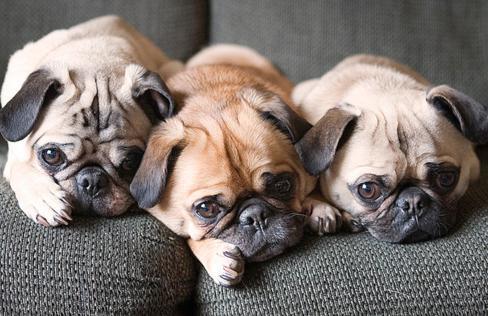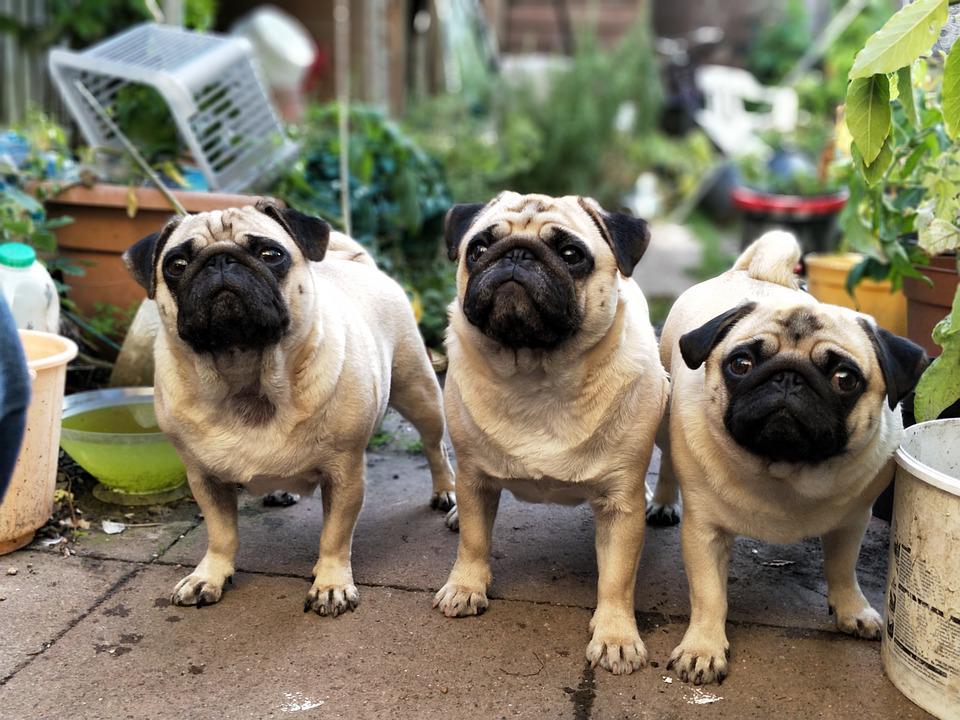The first image is the image on the left, the second image is the image on the right. For the images shown, is this caption "Three dogs are on a wooden step in one of the images." true? Answer yes or no. No. The first image is the image on the left, the second image is the image on the right. Analyze the images presented: Is the assertion "An image contains three pug dogs on a wooden picnic table." valid? Answer yes or no. No. 